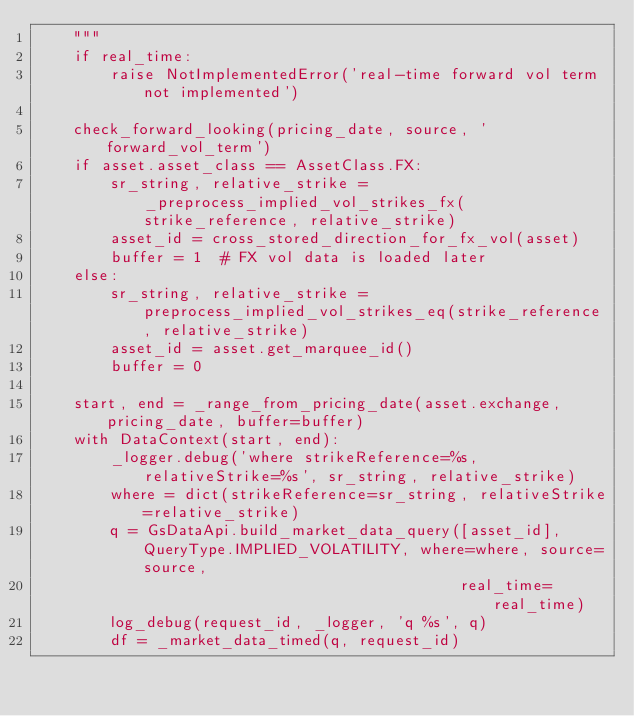Convert code to text. <code><loc_0><loc_0><loc_500><loc_500><_Python_>    """
    if real_time:
        raise NotImplementedError('real-time forward vol term not implemented')

    check_forward_looking(pricing_date, source, 'forward_vol_term')
    if asset.asset_class == AssetClass.FX:
        sr_string, relative_strike = _preprocess_implied_vol_strikes_fx(strike_reference, relative_strike)
        asset_id = cross_stored_direction_for_fx_vol(asset)
        buffer = 1  # FX vol data is loaded later
    else:
        sr_string, relative_strike = preprocess_implied_vol_strikes_eq(strike_reference, relative_strike)
        asset_id = asset.get_marquee_id()
        buffer = 0

    start, end = _range_from_pricing_date(asset.exchange, pricing_date, buffer=buffer)
    with DataContext(start, end):
        _logger.debug('where strikeReference=%s, relativeStrike=%s', sr_string, relative_strike)
        where = dict(strikeReference=sr_string, relativeStrike=relative_strike)
        q = GsDataApi.build_market_data_query([asset_id], QueryType.IMPLIED_VOLATILITY, where=where, source=source,
                                              real_time=real_time)
        log_debug(request_id, _logger, 'q %s', q)
        df = _market_data_timed(q, request_id)
</code> 